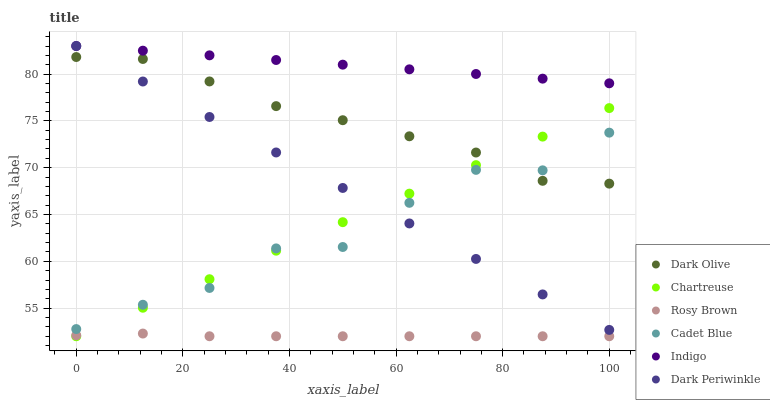Does Rosy Brown have the minimum area under the curve?
Answer yes or no. Yes. Does Indigo have the maximum area under the curve?
Answer yes or no. Yes. Does Dark Olive have the minimum area under the curve?
Answer yes or no. No. Does Dark Olive have the maximum area under the curve?
Answer yes or no. No. Is Dark Periwinkle the smoothest?
Answer yes or no. Yes. Is Cadet Blue the roughest?
Answer yes or no. Yes. Is Indigo the smoothest?
Answer yes or no. No. Is Indigo the roughest?
Answer yes or no. No. Does Chartreuse have the lowest value?
Answer yes or no. Yes. Does Dark Olive have the lowest value?
Answer yes or no. No. Does Dark Periwinkle have the highest value?
Answer yes or no. Yes. Does Dark Olive have the highest value?
Answer yes or no. No. Is Rosy Brown less than Dark Periwinkle?
Answer yes or no. Yes. Is Indigo greater than Rosy Brown?
Answer yes or no. Yes. Does Cadet Blue intersect Chartreuse?
Answer yes or no. Yes. Is Cadet Blue less than Chartreuse?
Answer yes or no. No. Is Cadet Blue greater than Chartreuse?
Answer yes or no. No. Does Rosy Brown intersect Dark Periwinkle?
Answer yes or no. No. 